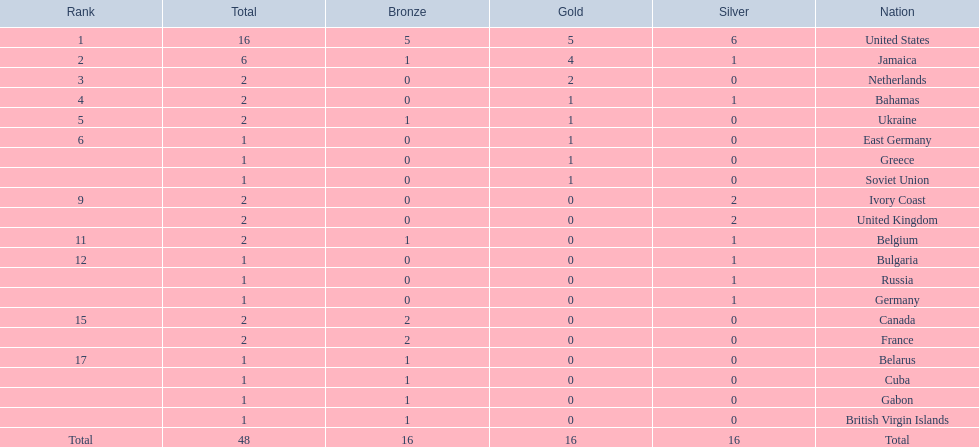What country won the most medals? United States. How many medals did the us win? 16. What is the most medals (after 16) that were won by a country? 6. Which country won 6 medals? Jamaica. 